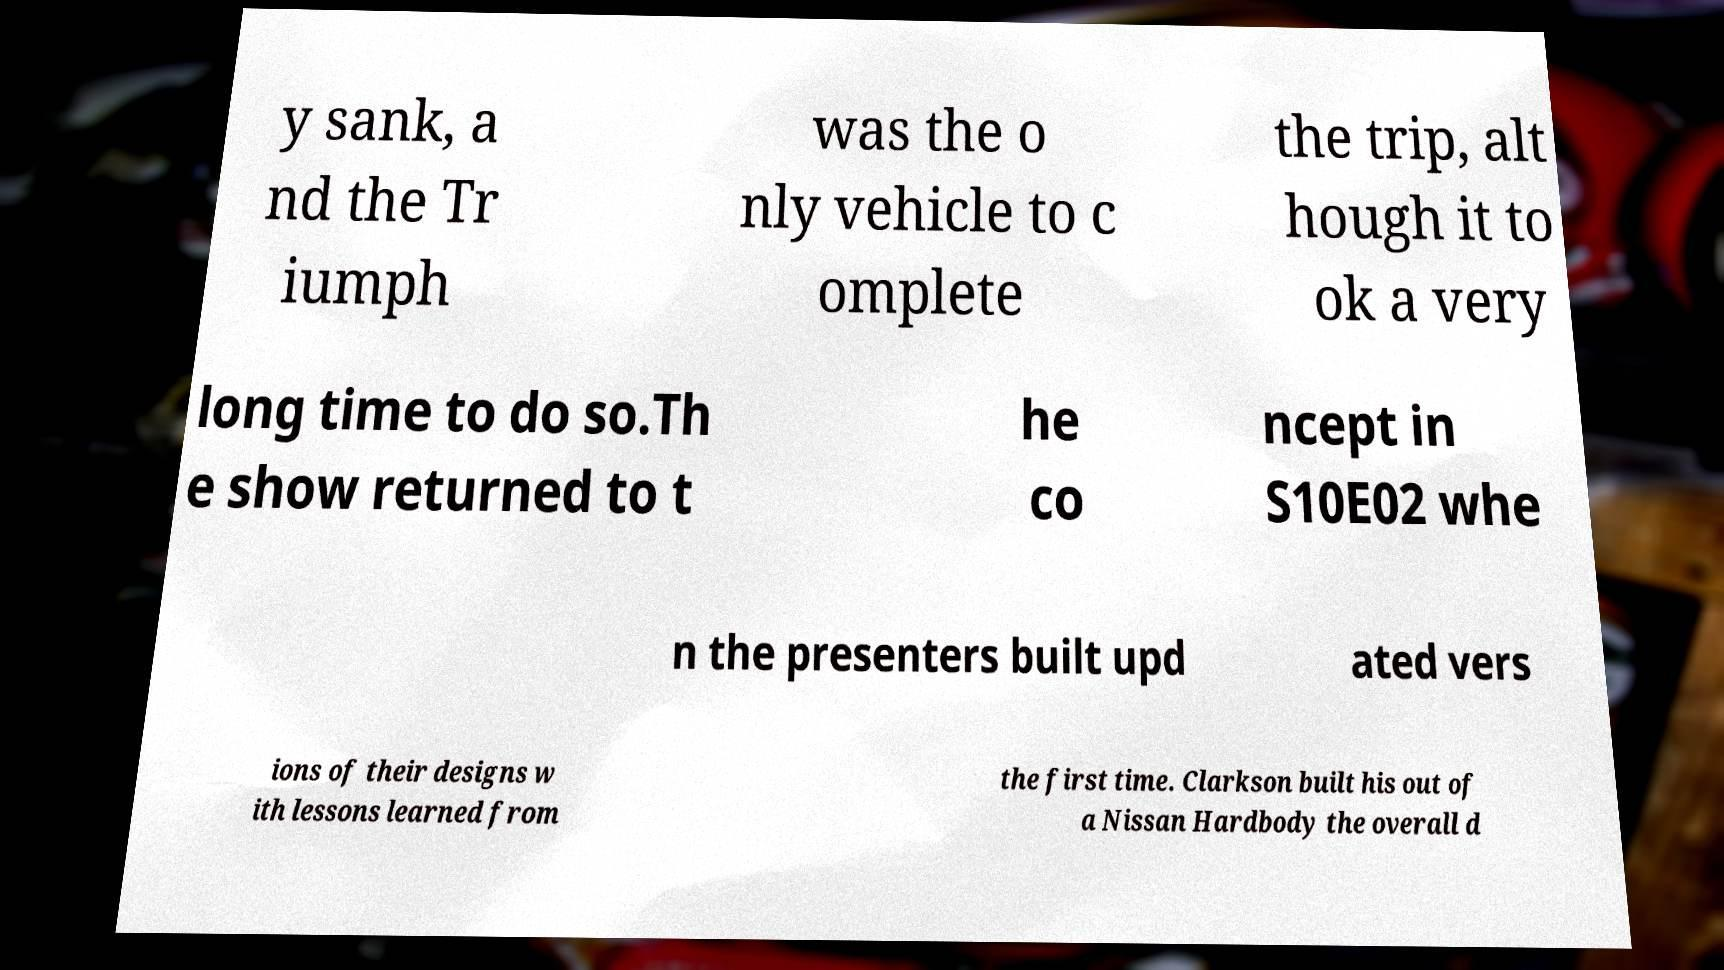For documentation purposes, I need the text within this image transcribed. Could you provide that? y sank, a nd the Tr iumph was the o nly vehicle to c omplete the trip, alt hough it to ok a very long time to do so.Th e show returned to t he co ncept in S10E02 whe n the presenters built upd ated vers ions of their designs w ith lessons learned from the first time. Clarkson built his out of a Nissan Hardbody the overall d 